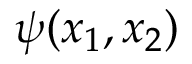Convert formula to latex. <formula><loc_0><loc_0><loc_500><loc_500>\psi ( x _ { 1 } , x _ { 2 } )</formula> 